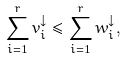Convert formula to latex. <formula><loc_0><loc_0><loc_500><loc_500>\sum _ { i = 1 } ^ { r } v _ { i } ^ { \downarrow } \leq \sum _ { i = 1 } ^ { r } w _ { i } ^ { \downarrow } ,</formula> 